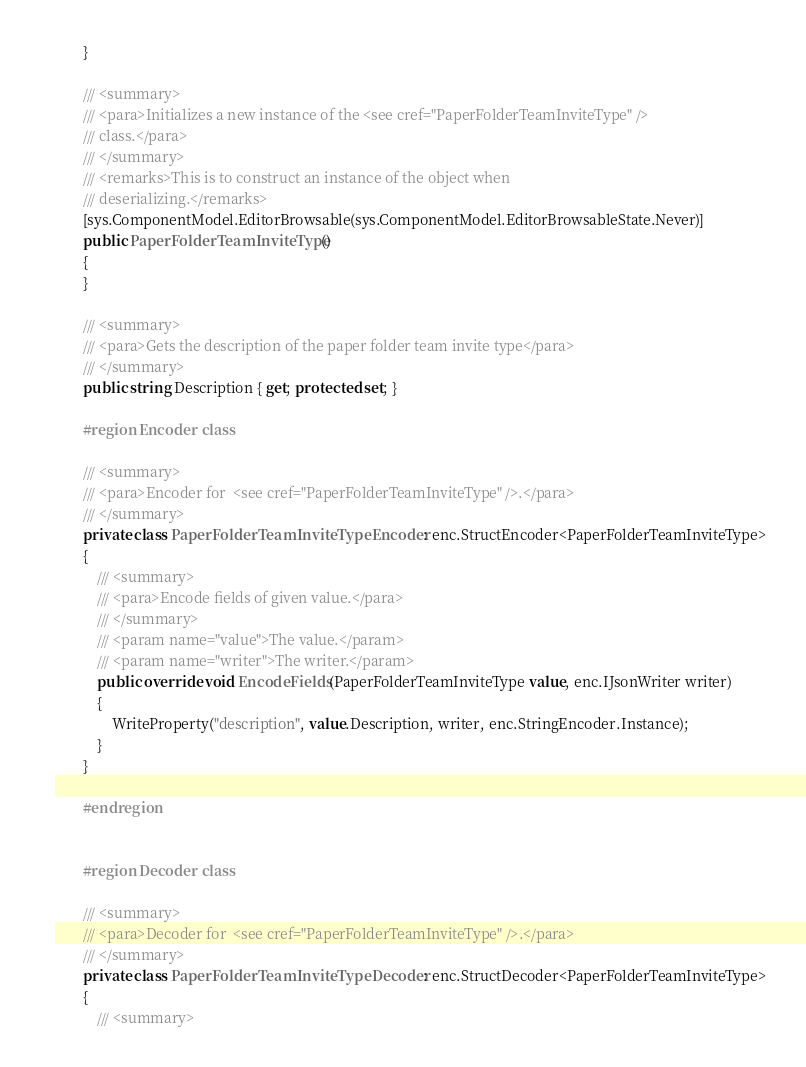<code> <loc_0><loc_0><loc_500><loc_500><_C#_>        }

        /// <summary>
        /// <para>Initializes a new instance of the <see cref="PaperFolderTeamInviteType" />
        /// class.</para>
        /// </summary>
        /// <remarks>This is to construct an instance of the object when
        /// deserializing.</remarks>
        [sys.ComponentModel.EditorBrowsable(sys.ComponentModel.EditorBrowsableState.Never)]
        public PaperFolderTeamInviteType()
        {
        }

        /// <summary>
        /// <para>Gets the description of the paper folder team invite type</para>
        /// </summary>
        public string Description { get; protected set; }

        #region Encoder class

        /// <summary>
        /// <para>Encoder for  <see cref="PaperFolderTeamInviteType" />.</para>
        /// </summary>
        private class PaperFolderTeamInviteTypeEncoder : enc.StructEncoder<PaperFolderTeamInviteType>
        {
            /// <summary>
            /// <para>Encode fields of given value.</para>
            /// </summary>
            /// <param name="value">The value.</param>
            /// <param name="writer">The writer.</param>
            public override void EncodeFields(PaperFolderTeamInviteType value, enc.IJsonWriter writer)
            {
                WriteProperty("description", value.Description, writer, enc.StringEncoder.Instance);
            }
        }

        #endregion


        #region Decoder class

        /// <summary>
        /// <para>Decoder for  <see cref="PaperFolderTeamInviteType" />.</para>
        /// </summary>
        private class PaperFolderTeamInviteTypeDecoder : enc.StructDecoder<PaperFolderTeamInviteType>
        {
            /// <summary></code> 